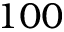<formula> <loc_0><loc_0><loc_500><loc_500>1 0 0</formula> 